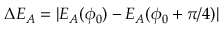<formula> <loc_0><loc_0><loc_500><loc_500>\Delta E _ { A } = | E _ { A } ( \phi _ { 0 } ) - E _ { A } ( \phi _ { 0 } + \pi / 4 ) |</formula> 